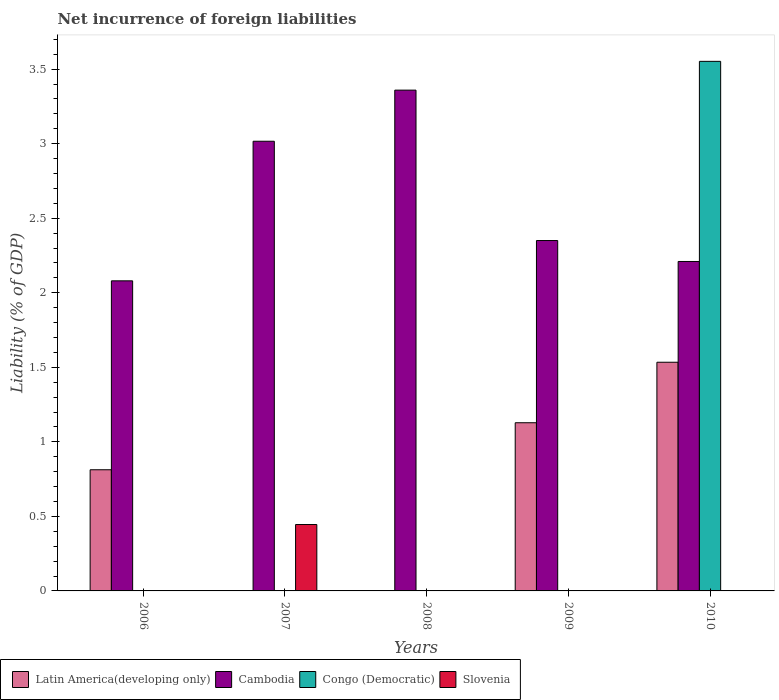How many different coloured bars are there?
Offer a very short reply. 4. Are the number of bars per tick equal to the number of legend labels?
Your answer should be compact. No. Are the number of bars on each tick of the X-axis equal?
Offer a very short reply. No. What is the net incurrence of foreign liabilities in Latin America(developing only) in 2006?
Provide a succinct answer. 0.81. Across all years, what is the maximum net incurrence of foreign liabilities in Cambodia?
Keep it short and to the point. 3.36. Across all years, what is the minimum net incurrence of foreign liabilities in Cambodia?
Give a very brief answer. 2.08. In which year was the net incurrence of foreign liabilities in Latin America(developing only) maximum?
Provide a short and direct response. 2010. What is the total net incurrence of foreign liabilities in Cambodia in the graph?
Ensure brevity in your answer.  13.02. What is the difference between the net incurrence of foreign liabilities in Cambodia in 2007 and that in 2008?
Keep it short and to the point. -0.34. What is the difference between the net incurrence of foreign liabilities in Latin America(developing only) in 2007 and the net incurrence of foreign liabilities in Cambodia in 2006?
Your answer should be very brief. -2.08. What is the average net incurrence of foreign liabilities in Congo (Democratic) per year?
Provide a succinct answer. 0.71. In the year 2006, what is the difference between the net incurrence of foreign liabilities in Latin America(developing only) and net incurrence of foreign liabilities in Cambodia?
Your answer should be very brief. -1.27. In how many years, is the net incurrence of foreign liabilities in Cambodia greater than 2.5 %?
Offer a terse response. 2. What is the ratio of the net incurrence of foreign liabilities in Cambodia in 2006 to that in 2007?
Make the answer very short. 0.69. Is the net incurrence of foreign liabilities in Cambodia in 2009 less than that in 2010?
Give a very brief answer. No. What is the difference between the highest and the second highest net incurrence of foreign liabilities in Cambodia?
Your answer should be compact. 0.34. What is the difference between the highest and the lowest net incurrence of foreign liabilities in Latin America(developing only)?
Give a very brief answer. 1.53. Is the sum of the net incurrence of foreign liabilities in Cambodia in 2008 and 2010 greater than the maximum net incurrence of foreign liabilities in Slovenia across all years?
Ensure brevity in your answer.  Yes. How many bars are there?
Ensure brevity in your answer.  10. Are all the bars in the graph horizontal?
Your response must be concise. No. How many years are there in the graph?
Provide a short and direct response. 5. Does the graph contain any zero values?
Your answer should be compact. Yes. Where does the legend appear in the graph?
Keep it short and to the point. Bottom left. What is the title of the graph?
Your answer should be very brief. Net incurrence of foreign liabilities. What is the label or title of the Y-axis?
Offer a very short reply. Liability (% of GDP). What is the Liability (% of GDP) in Latin America(developing only) in 2006?
Make the answer very short. 0.81. What is the Liability (% of GDP) of Cambodia in 2006?
Provide a short and direct response. 2.08. What is the Liability (% of GDP) of Slovenia in 2006?
Provide a succinct answer. 0. What is the Liability (% of GDP) of Cambodia in 2007?
Ensure brevity in your answer.  3.02. What is the Liability (% of GDP) in Slovenia in 2007?
Your response must be concise. 0.45. What is the Liability (% of GDP) of Cambodia in 2008?
Offer a terse response. 3.36. What is the Liability (% of GDP) of Latin America(developing only) in 2009?
Give a very brief answer. 1.13. What is the Liability (% of GDP) of Cambodia in 2009?
Keep it short and to the point. 2.35. What is the Liability (% of GDP) of Latin America(developing only) in 2010?
Ensure brevity in your answer.  1.53. What is the Liability (% of GDP) of Cambodia in 2010?
Your answer should be very brief. 2.21. What is the Liability (% of GDP) in Congo (Democratic) in 2010?
Offer a very short reply. 3.55. Across all years, what is the maximum Liability (% of GDP) in Latin America(developing only)?
Offer a terse response. 1.53. Across all years, what is the maximum Liability (% of GDP) of Cambodia?
Offer a terse response. 3.36. Across all years, what is the maximum Liability (% of GDP) of Congo (Democratic)?
Ensure brevity in your answer.  3.55. Across all years, what is the maximum Liability (% of GDP) of Slovenia?
Your response must be concise. 0.45. Across all years, what is the minimum Liability (% of GDP) in Cambodia?
Ensure brevity in your answer.  2.08. What is the total Liability (% of GDP) in Latin America(developing only) in the graph?
Provide a short and direct response. 3.48. What is the total Liability (% of GDP) in Cambodia in the graph?
Make the answer very short. 13.02. What is the total Liability (% of GDP) in Congo (Democratic) in the graph?
Offer a terse response. 3.55. What is the total Liability (% of GDP) in Slovenia in the graph?
Provide a short and direct response. 0.45. What is the difference between the Liability (% of GDP) of Cambodia in 2006 and that in 2007?
Offer a terse response. -0.94. What is the difference between the Liability (% of GDP) in Cambodia in 2006 and that in 2008?
Give a very brief answer. -1.28. What is the difference between the Liability (% of GDP) of Latin America(developing only) in 2006 and that in 2009?
Provide a short and direct response. -0.32. What is the difference between the Liability (% of GDP) in Cambodia in 2006 and that in 2009?
Your answer should be compact. -0.27. What is the difference between the Liability (% of GDP) of Latin America(developing only) in 2006 and that in 2010?
Your answer should be very brief. -0.72. What is the difference between the Liability (% of GDP) of Cambodia in 2006 and that in 2010?
Ensure brevity in your answer.  -0.13. What is the difference between the Liability (% of GDP) in Cambodia in 2007 and that in 2008?
Your answer should be very brief. -0.34. What is the difference between the Liability (% of GDP) in Cambodia in 2007 and that in 2009?
Provide a short and direct response. 0.67. What is the difference between the Liability (% of GDP) in Cambodia in 2007 and that in 2010?
Offer a very short reply. 0.81. What is the difference between the Liability (% of GDP) in Cambodia in 2008 and that in 2010?
Give a very brief answer. 1.15. What is the difference between the Liability (% of GDP) of Latin America(developing only) in 2009 and that in 2010?
Offer a terse response. -0.41. What is the difference between the Liability (% of GDP) in Cambodia in 2009 and that in 2010?
Offer a terse response. 0.14. What is the difference between the Liability (% of GDP) of Latin America(developing only) in 2006 and the Liability (% of GDP) of Cambodia in 2007?
Your answer should be compact. -2.2. What is the difference between the Liability (% of GDP) of Latin America(developing only) in 2006 and the Liability (% of GDP) of Slovenia in 2007?
Your answer should be very brief. 0.37. What is the difference between the Liability (% of GDP) of Cambodia in 2006 and the Liability (% of GDP) of Slovenia in 2007?
Offer a terse response. 1.63. What is the difference between the Liability (% of GDP) of Latin America(developing only) in 2006 and the Liability (% of GDP) of Cambodia in 2008?
Offer a terse response. -2.55. What is the difference between the Liability (% of GDP) in Latin America(developing only) in 2006 and the Liability (% of GDP) in Cambodia in 2009?
Give a very brief answer. -1.54. What is the difference between the Liability (% of GDP) of Latin America(developing only) in 2006 and the Liability (% of GDP) of Cambodia in 2010?
Your answer should be compact. -1.4. What is the difference between the Liability (% of GDP) in Latin America(developing only) in 2006 and the Liability (% of GDP) in Congo (Democratic) in 2010?
Make the answer very short. -2.74. What is the difference between the Liability (% of GDP) in Cambodia in 2006 and the Liability (% of GDP) in Congo (Democratic) in 2010?
Your answer should be very brief. -1.47. What is the difference between the Liability (% of GDP) of Cambodia in 2007 and the Liability (% of GDP) of Congo (Democratic) in 2010?
Your answer should be compact. -0.54. What is the difference between the Liability (% of GDP) of Cambodia in 2008 and the Liability (% of GDP) of Congo (Democratic) in 2010?
Offer a very short reply. -0.19. What is the difference between the Liability (% of GDP) in Latin America(developing only) in 2009 and the Liability (% of GDP) in Cambodia in 2010?
Your answer should be very brief. -1.08. What is the difference between the Liability (% of GDP) of Latin America(developing only) in 2009 and the Liability (% of GDP) of Congo (Democratic) in 2010?
Provide a succinct answer. -2.42. What is the difference between the Liability (% of GDP) in Cambodia in 2009 and the Liability (% of GDP) in Congo (Democratic) in 2010?
Provide a short and direct response. -1.2. What is the average Liability (% of GDP) of Latin America(developing only) per year?
Your response must be concise. 0.69. What is the average Liability (% of GDP) of Cambodia per year?
Provide a succinct answer. 2.6. What is the average Liability (% of GDP) of Congo (Democratic) per year?
Give a very brief answer. 0.71. What is the average Liability (% of GDP) in Slovenia per year?
Give a very brief answer. 0.09. In the year 2006, what is the difference between the Liability (% of GDP) in Latin America(developing only) and Liability (% of GDP) in Cambodia?
Make the answer very short. -1.27. In the year 2007, what is the difference between the Liability (% of GDP) in Cambodia and Liability (% of GDP) in Slovenia?
Offer a terse response. 2.57. In the year 2009, what is the difference between the Liability (% of GDP) in Latin America(developing only) and Liability (% of GDP) in Cambodia?
Ensure brevity in your answer.  -1.22. In the year 2010, what is the difference between the Liability (% of GDP) of Latin America(developing only) and Liability (% of GDP) of Cambodia?
Your response must be concise. -0.68. In the year 2010, what is the difference between the Liability (% of GDP) in Latin America(developing only) and Liability (% of GDP) in Congo (Democratic)?
Offer a very short reply. -2.02. In the year 2010, what is the difference between the Liability (% of GDP) in Cambodia and Liability (% of GDP) in Congo (Democratic)?
Provide a succinct answer. -1.34. What is the ratio of the Liability (% of GDP) of Cambodia in 2006 to that in 2007?
Offer a very short reply. 0.69. What is the ratio of the Liability (% of GDP) of Cambodia in 2006 to that in 2008?
Provide a short and direct response. 0.62. What is the ratio of the Liability (% of GDP) in Latin America(developing only) in 2006 to that in 2009?
Make the answer very short. 0.72. What is the ratio of the Liability (% of GDP) of Cambodia in 2006 to that in 2009?
Your answer should be very brief. 0.89. What is the ratio of the Liability (% of GDP) in Latin America(developing only) in 2006 to that in 2010?
Keep it short and to the point. 0.53. What is the ratio of the Liability (% of GDP) in Cambodia in 2006 to that in 2010?
Provide a succinct answer. 0.94. What is the ratio of the Liability (% of GDP) of Cambodia in 2007 to that in 2008?
Provide a succinct answer. 0.9. What is the ratio of the Liability (% of GDP) of Cambodia in 2007 to that in 2009?
Keep it short and to the point. 1.28. What is the ratio of the Liability (% of GDP) in Cambodia in 2007 to that in 2010?
Ensure brevity in your answer.  1.36. What is the ratio of the Liability (% of GDP) in Cambodia in 2008 to that in 2009?
Provide a short and direct response. 1.43. What is the ratio of the Liability (% of GDP) of Cambodia in 2008 to that in 2010?
Keep it short and to the point. 1.52. What is the ratio of the Liability (% of GDP) of Latin America(developing only) in 2009 to that in 2010?
Keep it short and to the point. 0.74. What is the ratio of the Liability (% of GDP) of Cambodia in 2009 to that in 2010?
Offer a terse response. 1.06. What is the difference between the highest and the second highest Liability (% of GDP) in Latin America(developing only)?
Provide a succinct answer. 0.41. What is the difference between the highest and the second highest Liability (% of GDP) of Cambodia?
Give a very brief answer. 0.34. What is the difference between the highest and the lowest Liability (% of GDP) in Latin America(developing only)?
Your answer should be compact. 1.53. What is the difference between the highest and the lowest Liability (% of GDP) of Cambodia?
Provide a short and direct response. 1.28. What is the difference between the highest and the lowest Liability (% of GDP) in Congo (Democratic)?
Offer a terse response. 3.55. What is the difference between the highest and the lowest Liability (% of GDP) of Slovenia?
Keep it short and to the point. 0.45. 